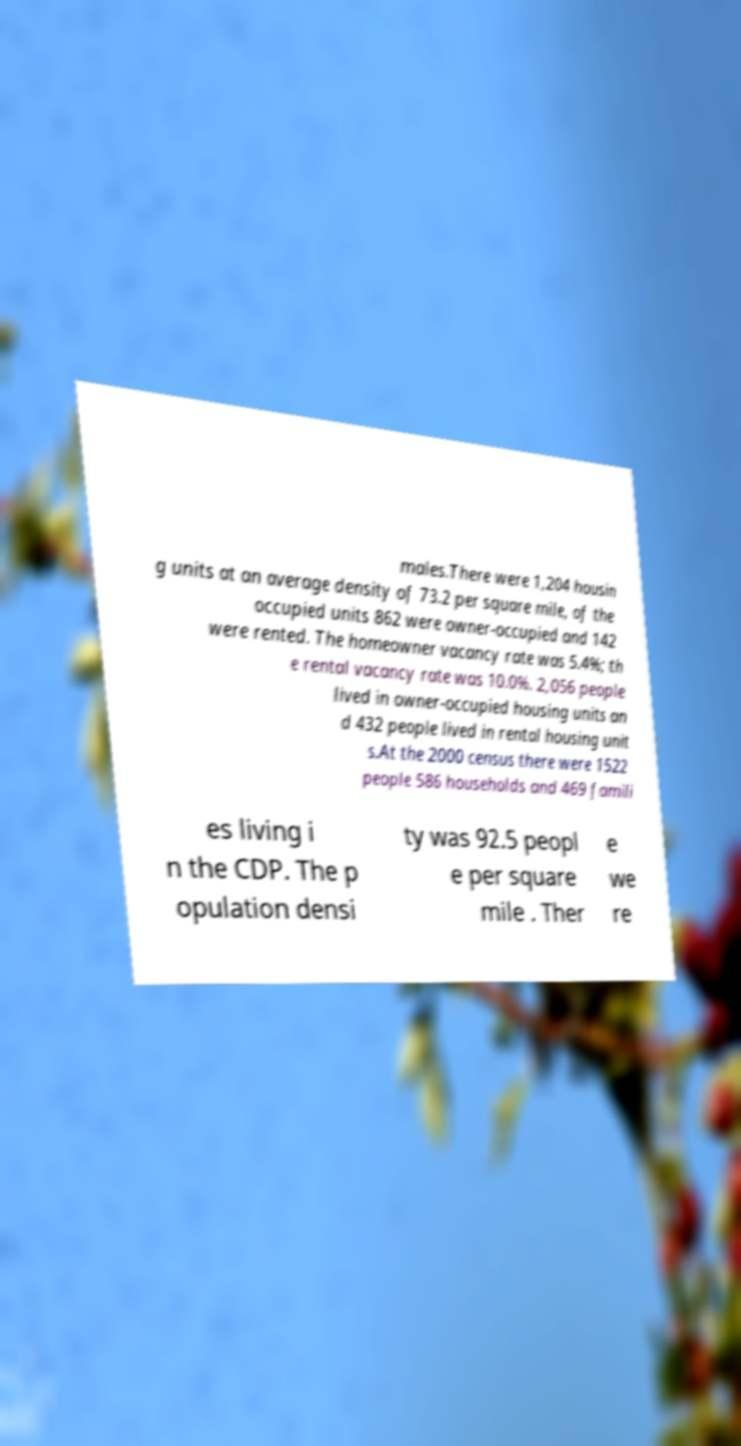For documentation purposes, I need the text within this image transcribed. Could you provide that? males.There were 1,204 housin g units at an average density of 73.2 per square mile, of the occupied units 862 were owner-occupied and 142 were rented. The homeowner vacancy rate was 5.4%; th e rental vacancy rate was 10.0%. 2,056 people lived in owner-occupied housing units an d 432 people lived in rental housing unit s.At the 2000 census there were 1522 people 586 households and 469 famili es living i n the CDP. The p opulation densi ty was 92.5 peopl e per square mile . Ther e we re 